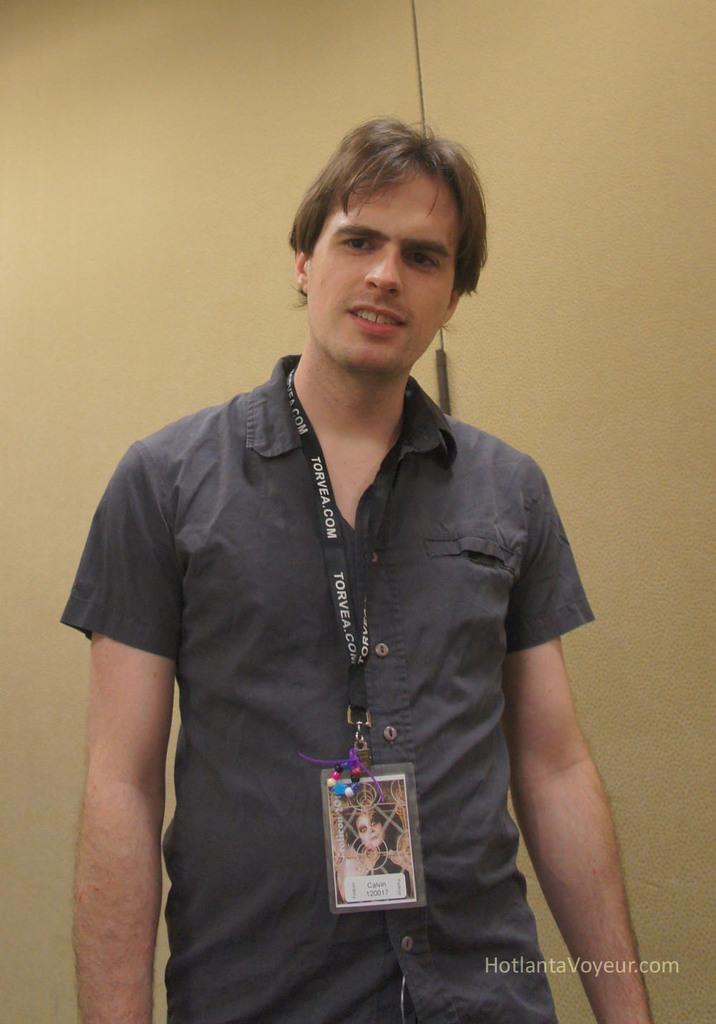Can you describe this image briefly? In this picture there is a man standing and wire tag. In the background of the image it is cream color. In the bottom right side of the image we can see text. 